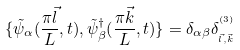Convert formula to latex. <formula><loc_0><loc_0><loc_500><loc_500>\{ \tilde { \psi } _ { \alpha } ( \frac { \pi \vec { l } } { L } , t ) , \tilde { \psi } _ { \beta } ^ { \dag } ( \frac { \pi \vec { k } } { L } , t ) \} = \delta _ { \alpha \beta } \delta _ { _ { \vec { l } , \vec { k } } } ^ { ^ { ( 3 ) } }</formula> 